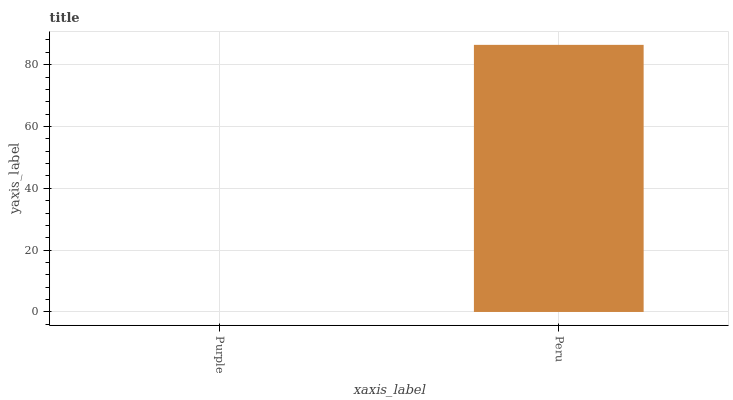Is Purple the minimum?
Answer yes or no. Yes. Is Peru the maximum?
Answer yes or no. Yes. Is Peru the minimum?
Answer yes or no. No. Is Peru greater than Purple?
Answer yes or no. Yes. Is Purple less than Peru?
Answer yes or no. Yes. Is Purple greater than Peru?
Answer yes or no. No. Is Peru less than Purple?
Answer yes or no. No. Is Peru the high median?
Answer yes or no. Yes. Is Purple the low median?
Answer yes or no. Yes. Is Purple the high median?
Answer yes or no. No. Is Peru the low median?
Answer yes or no. No. 